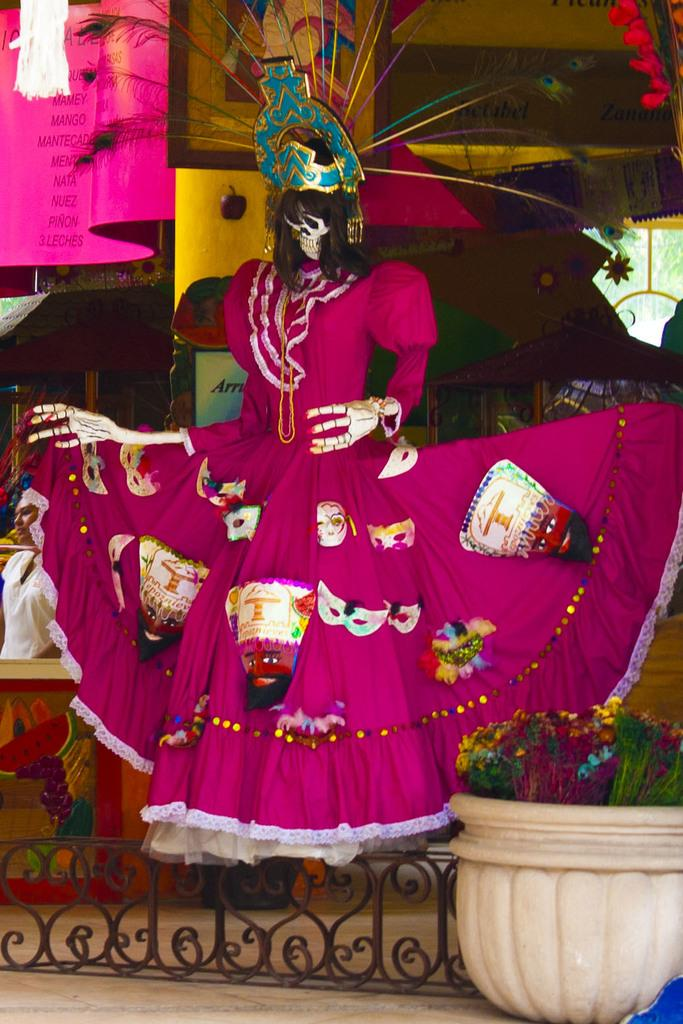What is the main subject of the image? There is a skeleton with clothes in the image. What else can be seen in the image besides the skeleton? There is a flower pot, a woman standing, a building, and a metal fence in the image. What type of suit is the skeleton wearing in the image? The skeleton is not wearing a suit; it is wearing clothes, as mentioned in the fact. How many arms does the skeleton have in the image? The skeleton has the typical number of arms for a human skeleton, which is two. However, since the skeleton is not a living person, it is not accurate to say it has arms. 